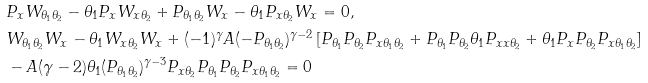<formula> <loc_0><loc_0><loc_500><loc_500>& P _ { x } W _ { \theta _ { 1 } \theta _ { 2 } } - \theta _ { 1 } P _ { x } W _ { x \theta _ { 2 } } + P _ { \theta _ { 1 } \theta _ { 2 } } W _ { x } - \theta _ { 1 } P _ { x \theta _ { 2 } } W _ { x } = 0 , \\ & W _ { \theta _ { 1 } \theta _ { 2 } } W _ { x } - \theta _ { 1 } W _ { x \theta _ { 2 } } W _ { x } + ( - 1 ) ^ { \gamma } A ( - P _ { \theta _ { 1 } \theta _ { 2 } } ) ^ { \gamma - 2 } \left [ P _ { \theta _ { 1 } } P _ { \theta _ { 2 } } P _ { x \theta _ { 1 } \theta _ { 2 } } + P _ { \theta _ { 1 } } P _ { \theta _ { 2 } } \theta _ { 1 } P _ { x x \theta _ { 2 } } + \theta _ { 1 } P _ { x } P _ { \theta _ { 2 } } P _ { x \theta _ { 1 } \theta _ { 2 } } \right ] \\ & - A ( \gamma - 2 ) \theta _ { 1 } ( P _ { \theta _ { 1 } \theta _ { 2 } } ) ^ { \gamma - 3 } P _ { x \theta _ { 2 } } P _ { \theta _ { 1 } } P _ { \theta _ { 2 } } P _ { x \theta _ { 1 } \theta _ { 2 } } = 0</formula> 